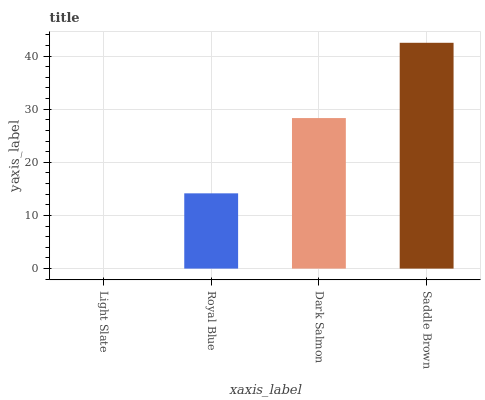Is Light Slate the minimum?
Answer yes or no. Yes. Is Saddle Brown the maximum?
Answer yes or no. Yes. Is Royal Blue the minimum?
Answer yes or no. No. Is Royal Blue the maximum?
Answer yes or no. No. Is Royal Blue greater than Light Slate?
Answer yes or no. Yes. Is Light Slate less than Royal Blue?
Answer yes or no. Yes. Is Light Slate greater than Royal Blue?
Answer yes or no. No. Is Royal Blue less than Light Slate?
Answer yes or no. No. Is Dark Salmon the high median?
Answer yes or no. Yes. Is Royal Blue the low median?
Answer yes or no. Yes. Is Royal Blue the high median?
Answer yes or no. No. Is Light Slate the low median?
Answer yes or no. No. 